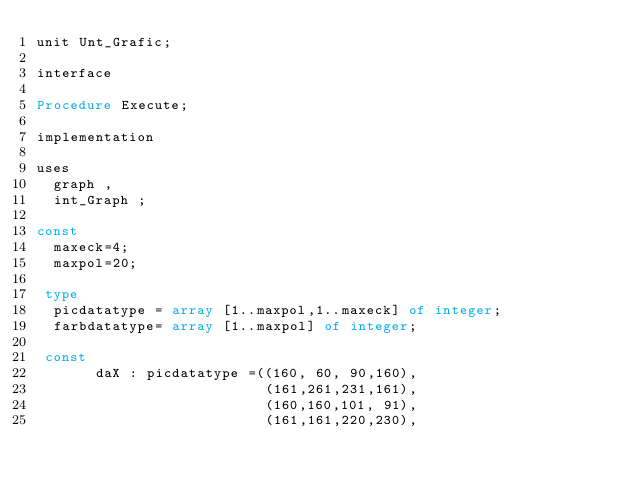<code> <loc_0><loc_0><loc_500><loc_500><_Pascal_>unit Unt_Grafic;

interface

Procedure Execute;

implementation

uses
  graph ,
  int_Graph ;

const
  maxeck=4;
  maxpol=20;

 type
  picdatatype = array [1..maxpol,1..maxeck] of integer;
  farbdatatype= array [1..maxpol] of integer;

 const
       daX : picdatatype =((160, 60, 90,160),
                           (161,261,231,161),
                           (160,160,101, 91),
                           (161,161,220,230),</code> 